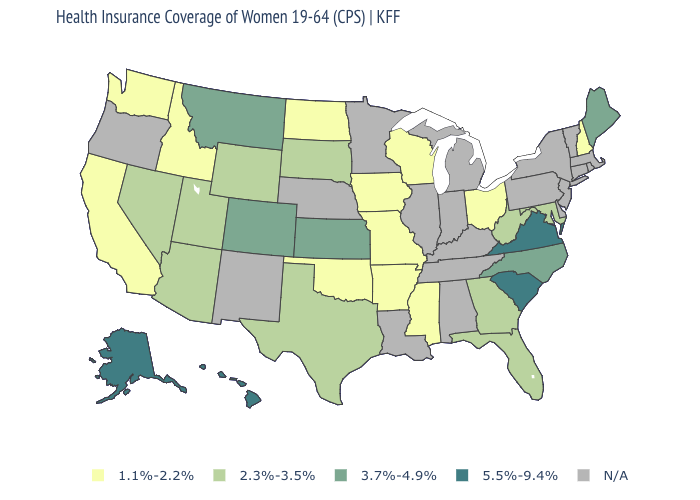Name the states that have a value in the range 3.7%-4.9%?
Give a very brief answer. Colorado, Kansas, Maine, Montana, North Carolina. Is the legend a continuous bar?
Answer briefly. No. Which states have the highest value in the USA?
Answer briefly. Alaska, Hawaii, South Carolina, Virginia. Does the first symbol in the legend represent the smallest category?
Answer briefly. Yes. Which states have the lowest value in the USA?
Give a very brief answer. Arkansas, California, Idaho, Iowa, Mississippi, Missouri, New Hampshire, North Dakota, Ohio, Oklahoma, Washington, Wisconsin. Name the states that have a value in the range 5.5%-9.4%?
Short answer required. Alaska, Hawaii, South Carolina, Virginia. Name the states that have a value in the range 2.3%-3.5%?
Quick response, please. Arizona, Florida, Georgia, Maryland, Nevada, South Dakota, Texas, Utah, West Virginia, Wyoming. What is the value of Florida?
Concise answer only. 2.3%-3.5%. Among the states that border North Carolina , does South Carolina have the highest value?
Answer briefly. Yes. What is the value of Vermont?
Concise answer only. N/A. What is the value of Vermont?
Be succinct. N/A. Among the states that border Georgia , does South Carolina have the highest value?
Answer briefly. Yes. Which states have the lowest value in the MidWest?
Give a very brief answer. Iowa, Missouri, North Dakota, Ohio, Wisconsin. What is the value of Wyoming?
Answer briefly. 2.3%-3.5%. What is the value of Wisconsin?
Write a very short answer. 1.1%-2.2%. 